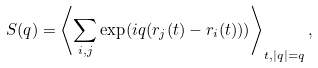<formula> <loc_0><loc_0><loc_500><loc_500>S ( q ) = \left < \sum _ { i , j } \exp ( i { q } ( { r } _ { j } ( t ) - { r } _ { i } ( t ) ) ) \right > _ { t , | { q } | = q } ,</formula> 